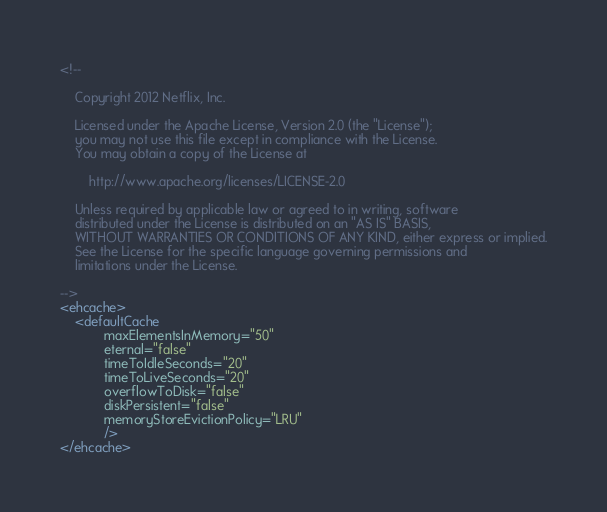Convert code to text. <code><loc_0><loc_0><loc_500><loc_500><_XML_><!--

    Copyright 2012 Netflix, Inc.

    Licensed under the Apache License, Version 2.0 (the "License");
    you may not use this file except in compliance with the License.
    You may obtain a copy of the License at

        http://www.apache.org/licenses/LICENSE-2.0

    Unless required by applicable law or agreed to in writing, software
    distributed under the License is distributed on an "AS IS" BASIS,
    WITHOUT WARRANTIES OR CONDITIONS OF ANY KIND, either express or implied.
    See the License for the specific language governing permissions and
    limitations under the License.

-->
<ehcache>
    <defaultCache
            maxElementsInMemory="50"
            eternal="false"
            timeToIdleSeconds="20"
            timeToLiveSeconds="20"
            overflowToDisk="false"
            diskPersistent="false"
            memoryStoreEvictionPolicy="LRU"
            />
</ehcache>
</code> 